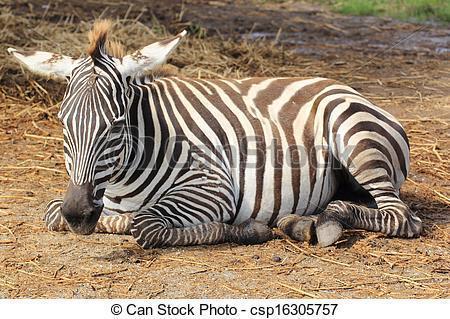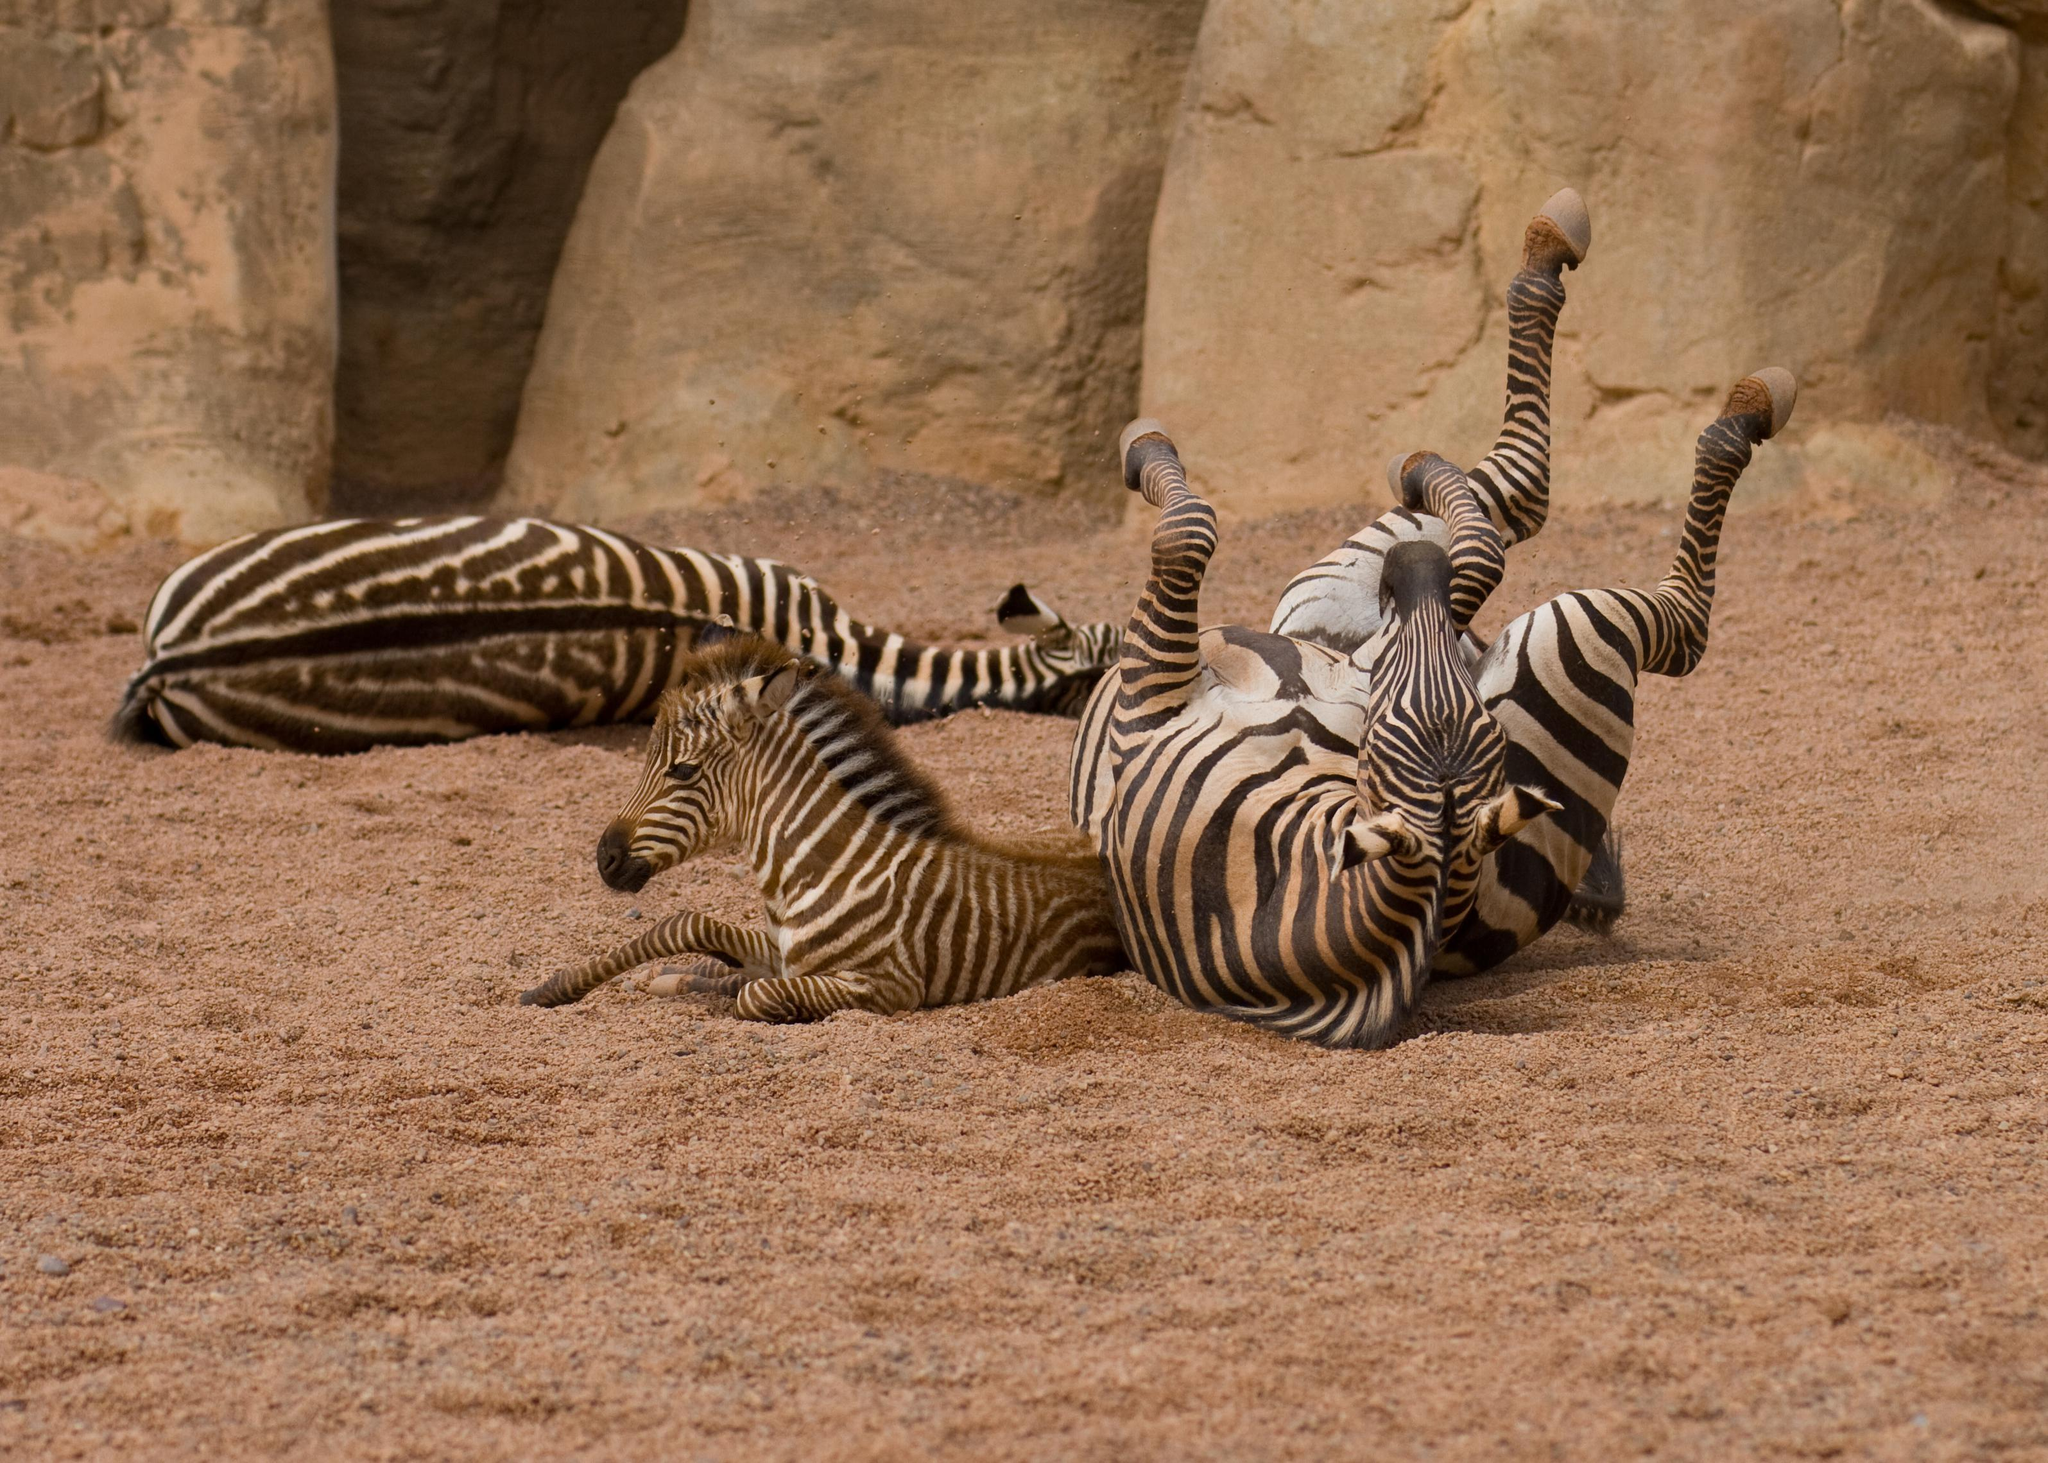The first image is the image on the left, the second image is the image on the right. For the images shown, is this caption "There are two zebras" true? Answer yes or no. No. The first image is the image on the left, the second image is the image on the right. Analyze the images presented: Is the assertion "One image includes a zebra lying flat on its side with its head also flat on the brown ground." valid? Answer yes or no. Yes. 